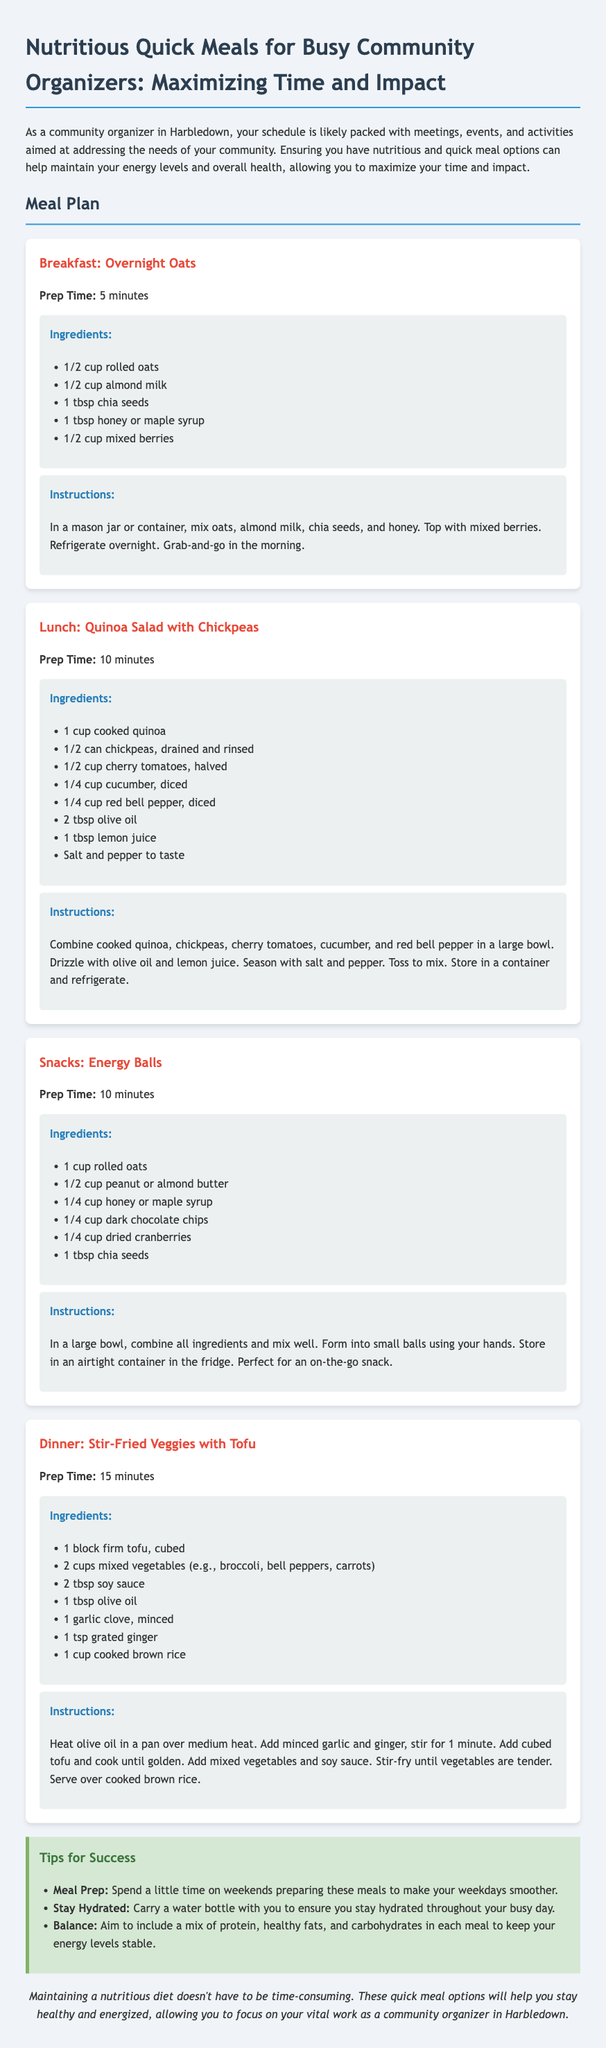What is the title of the document? The title is specified in the header of the document.
Answer: Nutritious Quick Meals for Busy Community Organizers How long does it take to prepare the Breakfast meal? The preparation time for the Breakfast meal is stated in the meal description.
Answer: 5 minutes What ingredient is used in the Lunch meal to add protein? The main protein source in the Lunch meal is listed under the ingredients.
Answer: Chickpeas What is a tip for success mentioned in the document? Tips for success are listed in a separate section, each focusing on meal preparation or lifestyle.
Answer: Meal Prep What is the primary carbohydrate source in the Dinner meal? The document specifies the carbohydrate source in the Dinner meal under ingredients.
Answer: Brown rice What is the prep time for the Snacks meal? The preparation time for the Snacks meal is included in the meal description.
Answer: 10 minutes How many main meals are described in the document? The total number of meals is indicated by the number of meal sections provided.
Answer: Four What type of meal is "Overnight Oats"? The meal classification is stated at the beginning of each meal section.
Answer: Breakfast What is the main cooking method used in the Dinner meal? The cooking method is described in the instructions for preparing the Dinner meal.
Answer: Stir-fried 